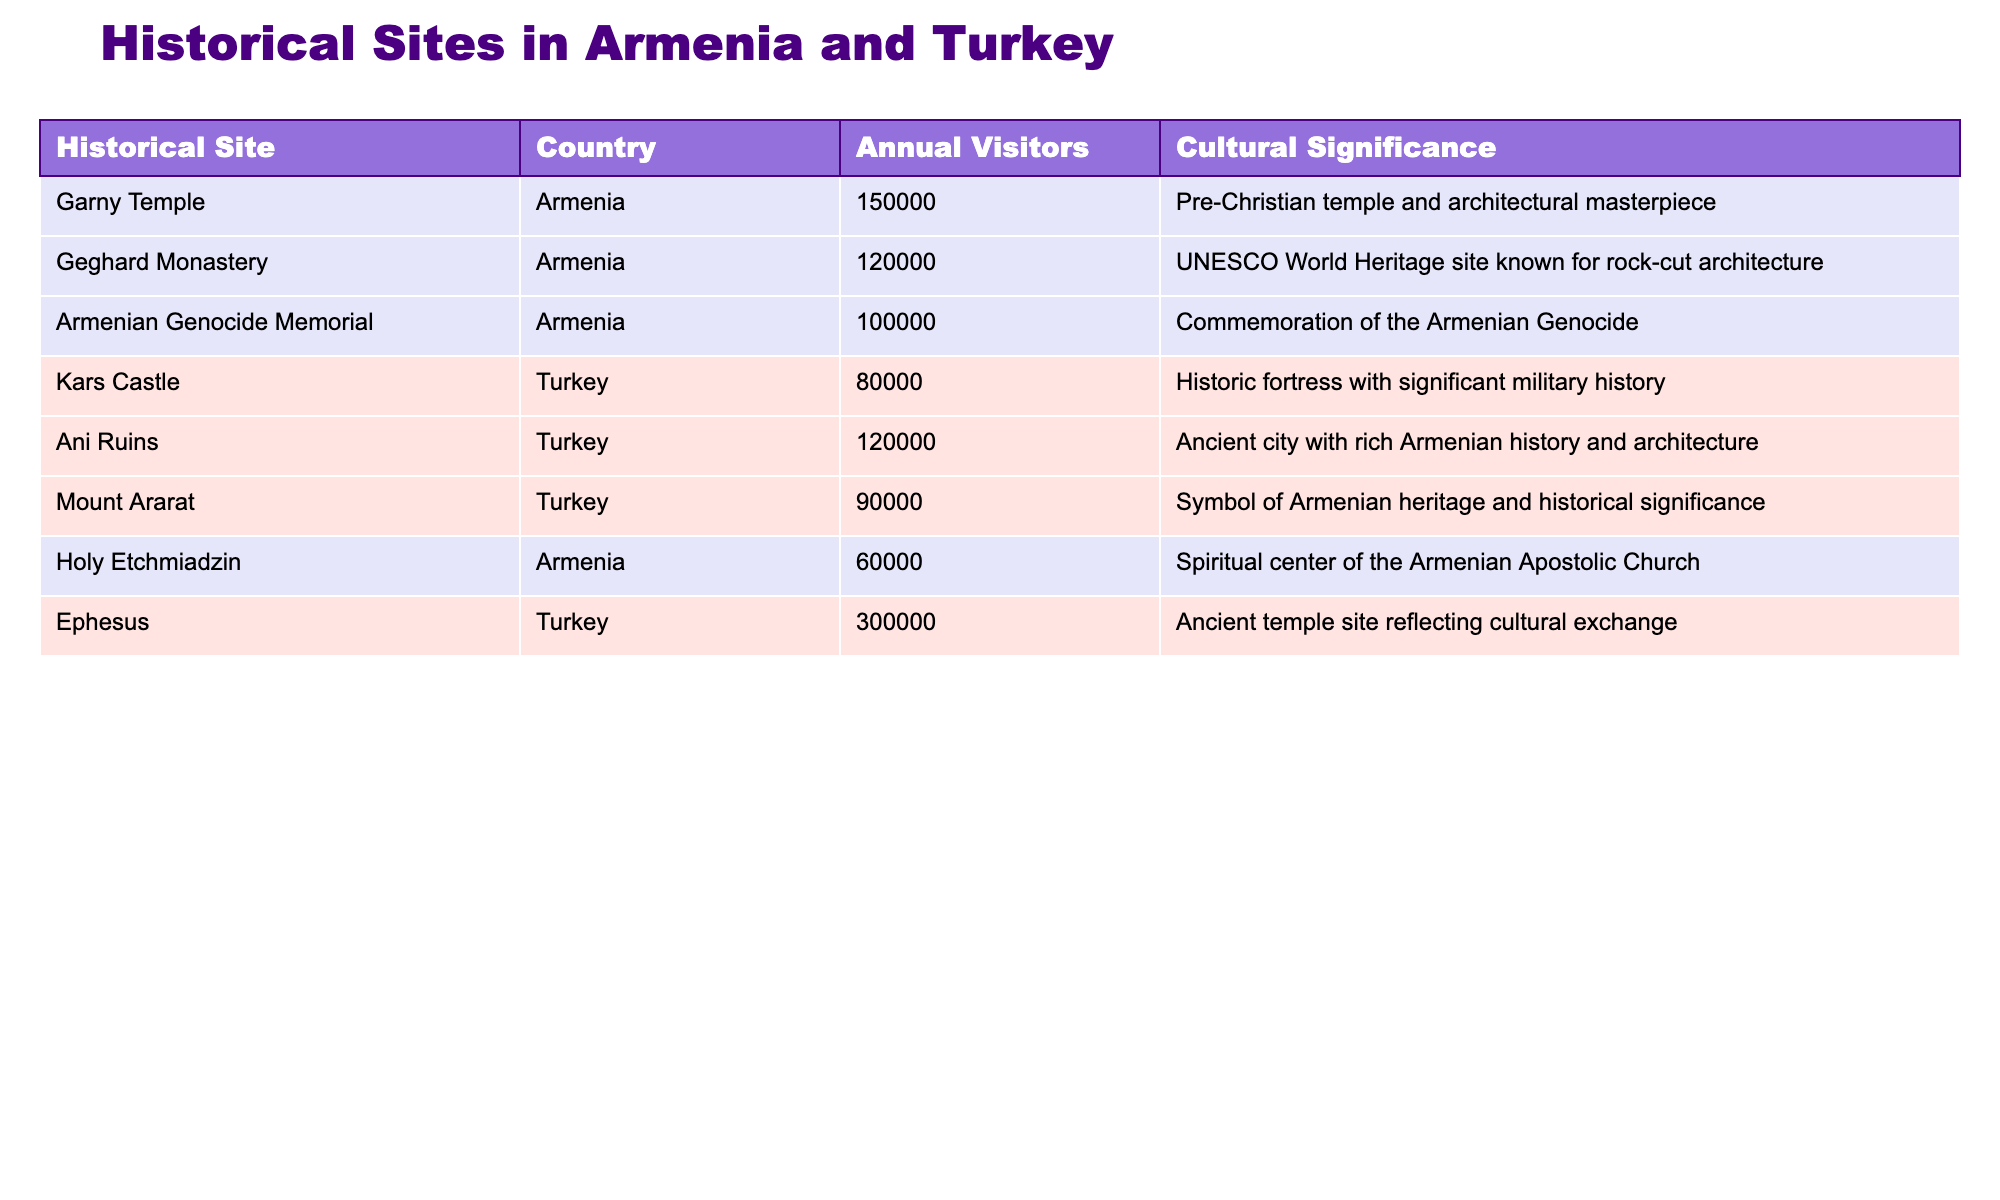What is the cultural significance of the Armenian Genocide Memorial? The table clearly states that the Armenian Genocide Memorial is a commemoration of the Armenian Genocide. This is directly listed under the 'Cultural Significance' column adjacent to the site.
Answer: Commemoration of the Armenian Genocide Which historical site in Turkey has the highest estimated annual visitors? By examining the ‘Annual Visitors (Estimated)’ for each site in Turkey, Ephesus is noted to have the highest number at 300,000, while other Turkish sites have fewer visitors.
Answer: Ephesus How many total annual visitors do the historical sites in Armenia attract? To find the total, add the estimated annual visitors of all Armenian sites: Garny Temple (150,000) + Geghard Monastery (120,000) + Armenian Genocide Memorial (100,000) + Holy Etchmiadzin (60,000) = 430,000 visitors.
Answer: 430000 Is Mount Ararat located in Armenia? The table shows that Mount Ararat is listed under Turkey, indicating it is located there instead of Armenia, despite its cultural significance to Armenians.
Answer: No Which site has a cultural significance related to rock-cut architecture? The table indicates that Geghard Monastery is known for its rock-cut architecture, as stated in the 'Cultural Significance' column associated with that site.
Answer: Geghard Monastery What is the difference in annual visitors between Ani Ruins and Kars Castle? To find the difference, subtract the visitors of Kars Castle (80,000) from the visitors of Ani Ruins (120,000): 120,000 - 80,000 = 40,000.
Answer: 40000 Which country has the lowest average annual visitors for its historical sites listed in the table? First, identify the total annual visitors for each country: Armenia (430,000) has 4 sites, so the average is 107,500; Turkey (390,000) has 3 sites, so the average is 130,000. Turkey has a higher average, so Armenia has the lowest average.
Answer: Armenia Is Ephesus significant to Armenian heritage? The table presents Ephesus purely as an ancient temple site reflecting cultural exchange but does not list it specifically as significant to Armenian heritage.
Answer: No What is the average annual visitors for Armenian historical sites? Total annual visitors for Armenia are 430,000 from 4 sites, so average is 430,000 / 4 = 107,500 visitors.
Answer: 107500 